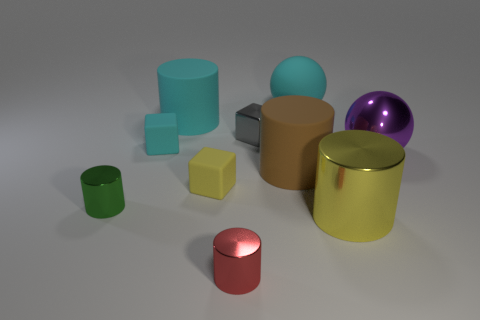How do the colors of the objects contribute to the overall composition? The diverse color palette, featuring green, yellow, brown, red, blue, purple, and metallic tones, provides a striking visual contrast that enhances the composition’s appeal and aids in distinguishing the individual shapes and materials. 